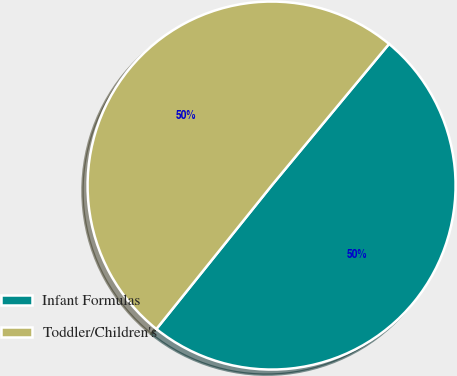<chart> <loc_0><loc_0><loc_500><loc_500><pie_chart><fcel>Infant Formulas<fcel>Toddler/Children's<nl><fcel>49.75%<fcel>50.25%<nl></chart> 